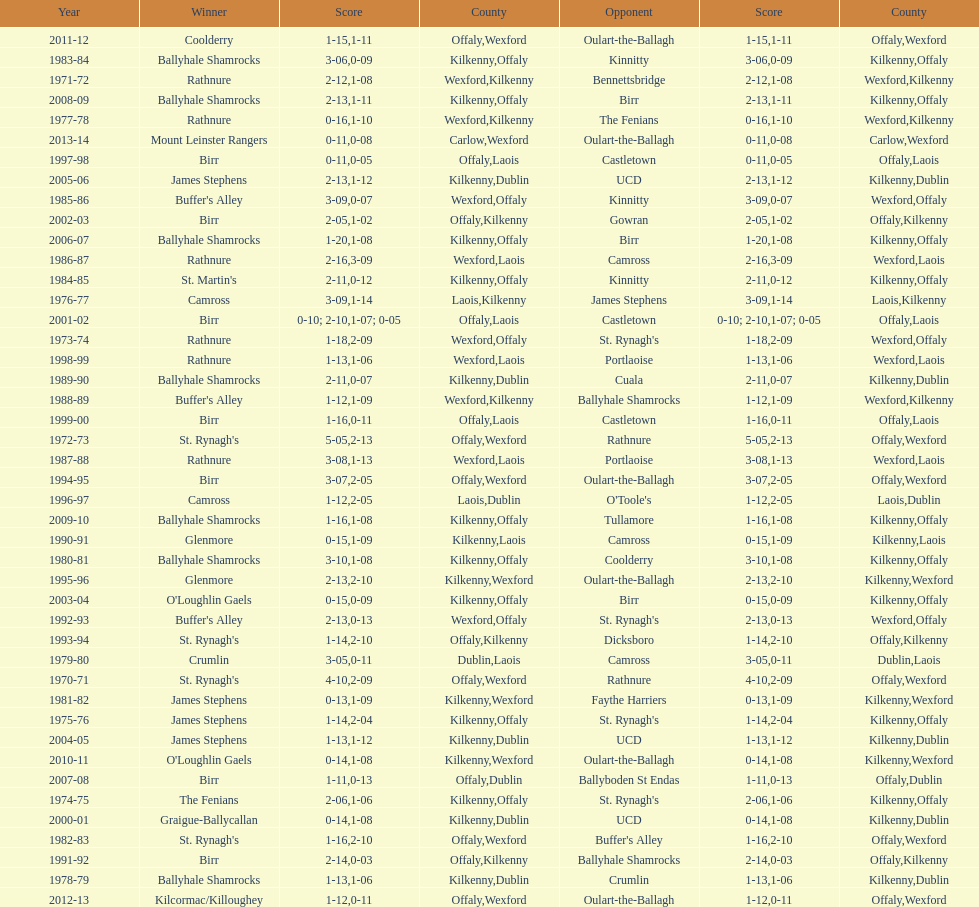Which team won the leinster senior club hurling championships previous to the last time birr won? Ballyhale Shamrocks. 